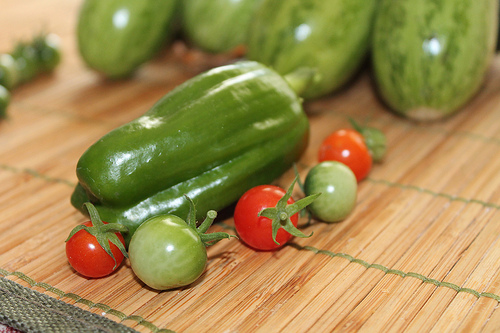<image>
Is there a tomato in front of the pepper? Yes. The tomato is positioned in front of the pepper, appearing closer to the camera viewpoint. 